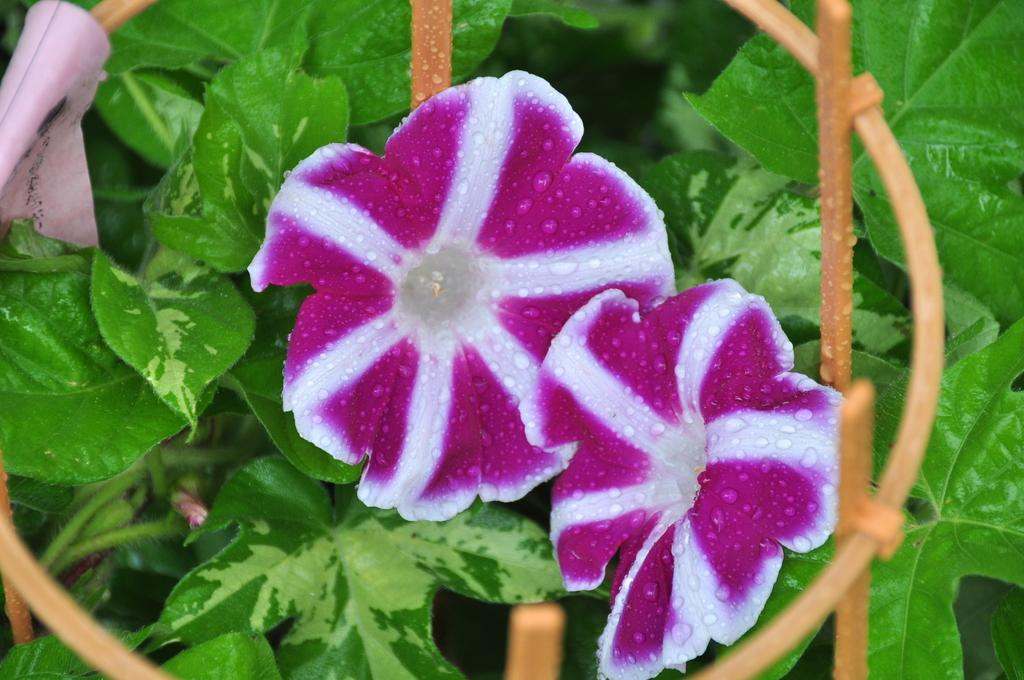What type of living organisms can be seen in the image? Plants can be seen in the image. How many flowers and buds are visible on the plants? The plants have two flowers and one bud. What is the purpose of the fence-like object around the flowers and bud? The fence-like object may be serving as a protective barrier or a decorative element for the plants. What can be seen on the left side of the image? There is an object on the left side of the image. What time of day is indicated by the hour on the sign in the image? There is no sign or hour present in the image; it features plants with flowers and buds, and a fence-like object. 